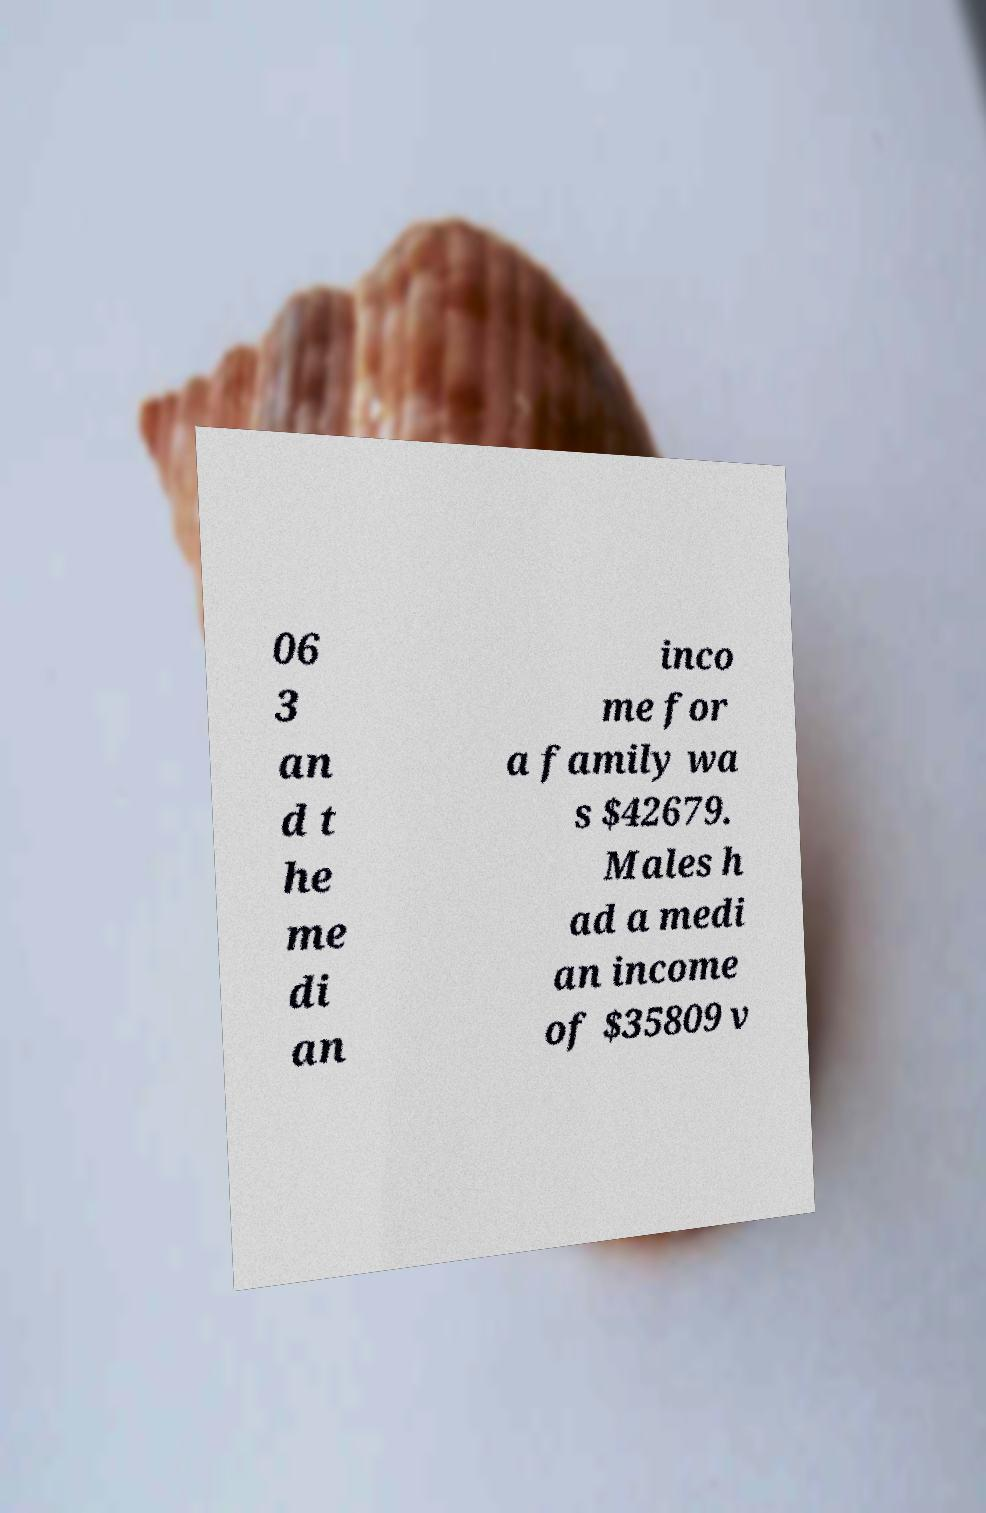Please identify and transcribe the text found in this image. 06 3 an d t he me di an inco me for a family wa s $42679. Males h ad a medi an income of $35809 v 